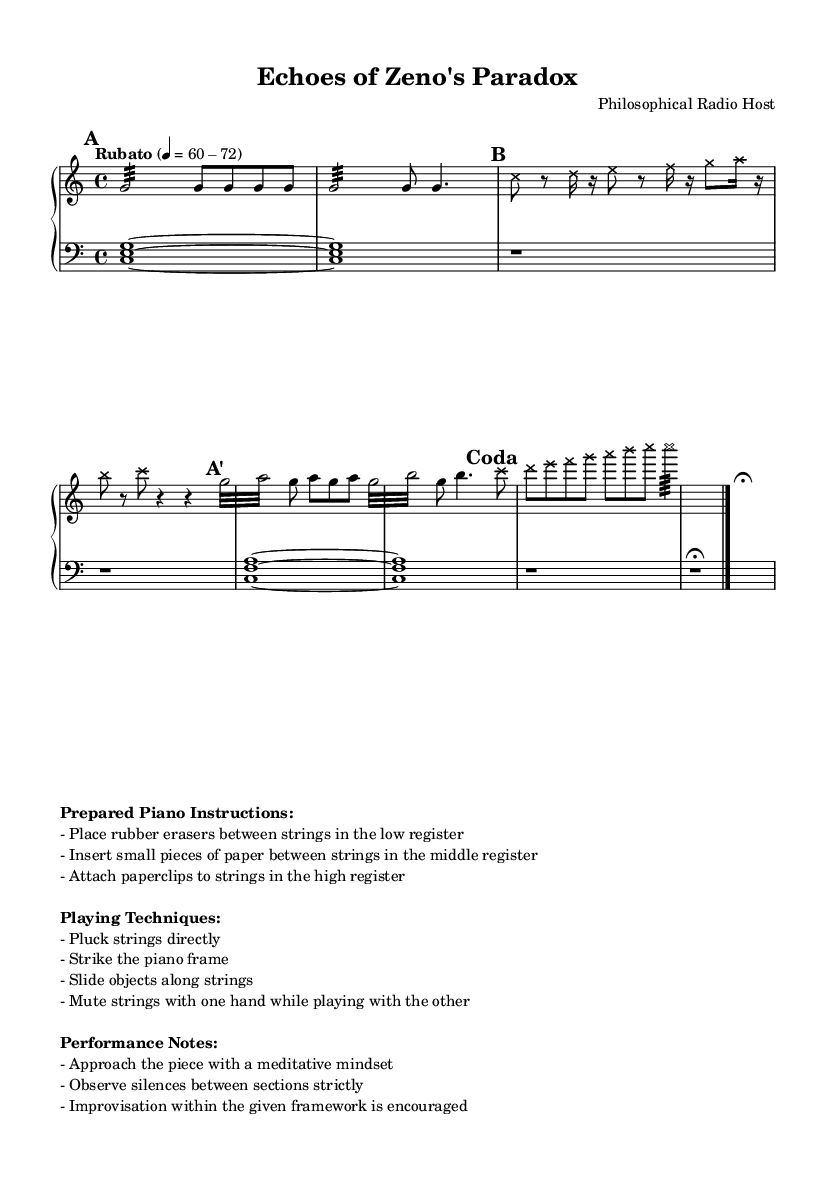What is the time signature of this music? The time signature indicated in the score is 4/4, which can be seen at the beginning of the global context in the code.
Answer: 4/4 What is the tempo marking of this piece? The tempo marking provided in the score is "Rubato," and it suggests a flexible tempo between 60 and 72 beats per minute. This can be verified in the global context section.
Answer: Rubato 60-72 How many sections are there in the piece? The piece is divided into four sections: A, B, A', and Coda. This is indicated by the marked headers in the upper staff.
Answer: Four What is the style of the note heads in section B? The note heads in section B are styled as crosses, which is specified in the markup and characterized by the override command in the code.
Answer: Cross What materials are used for preparation in this piece? The preparations specified include rubber erasers, small pieces of paper, and paperclips, which are detailed in the prepared piano instructions section of the markup.
Answer: Rubber erasers, paper, and paperclips What does the score indicate about performance mindset? The score indicates that performers should approach the piece with a meditative mindset, as mentioned in the performance notes section of the markup.
Answer: Meditative mindset How should silences be treated between sections? The performance notes specify that silences between sections should be observed strictly, emphasizing the importance of silence in this experimental piece.
Answer: Strictly 